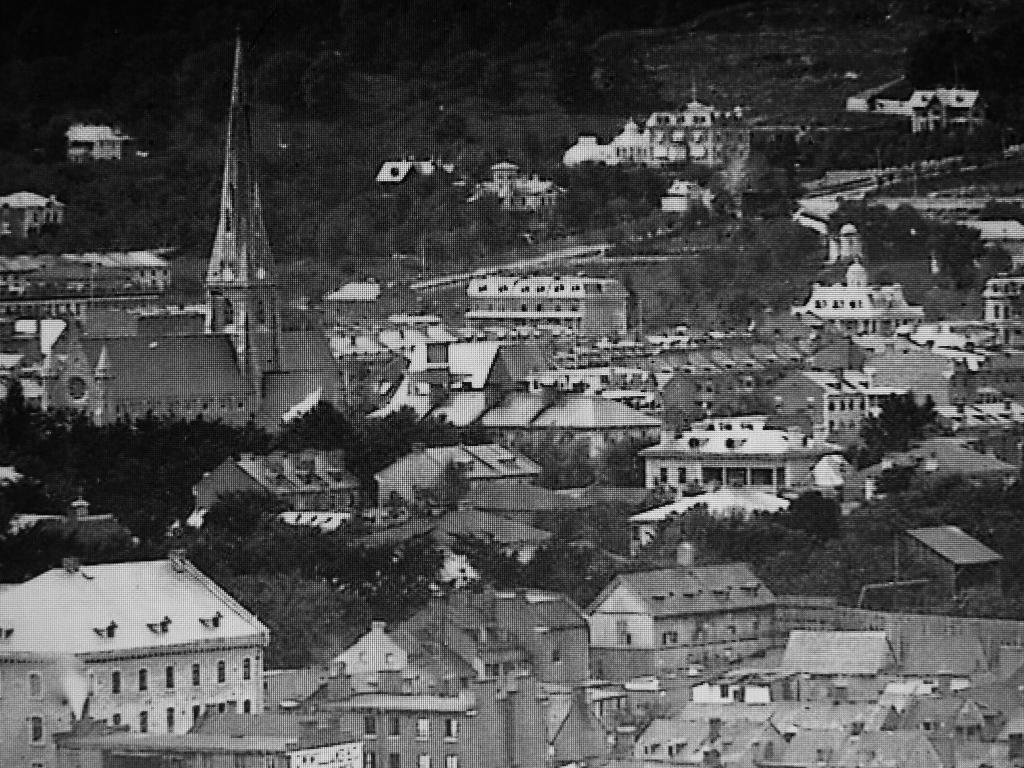How would you summarize this image in a sentence or two? It looks like an old black and white picture. We can see there are houses and trees. Behind the houses, it looks like a hill. 